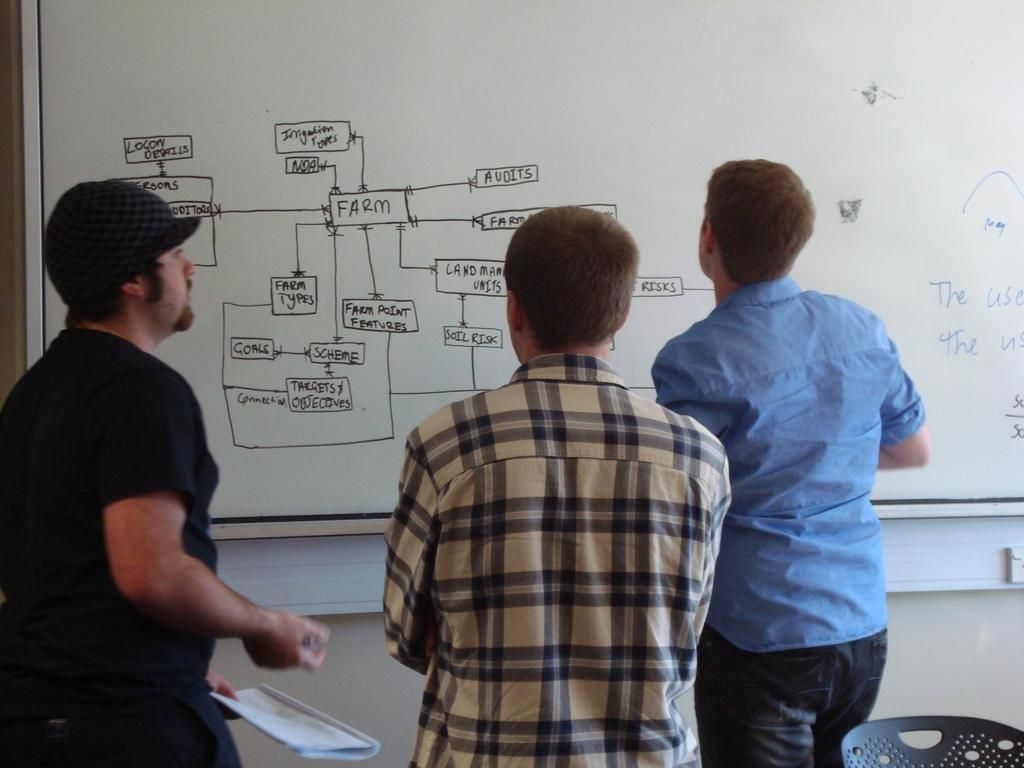Provide a one-sentence caption for the provided image. A group of men looking at a whiteboard with the Farm on it. 